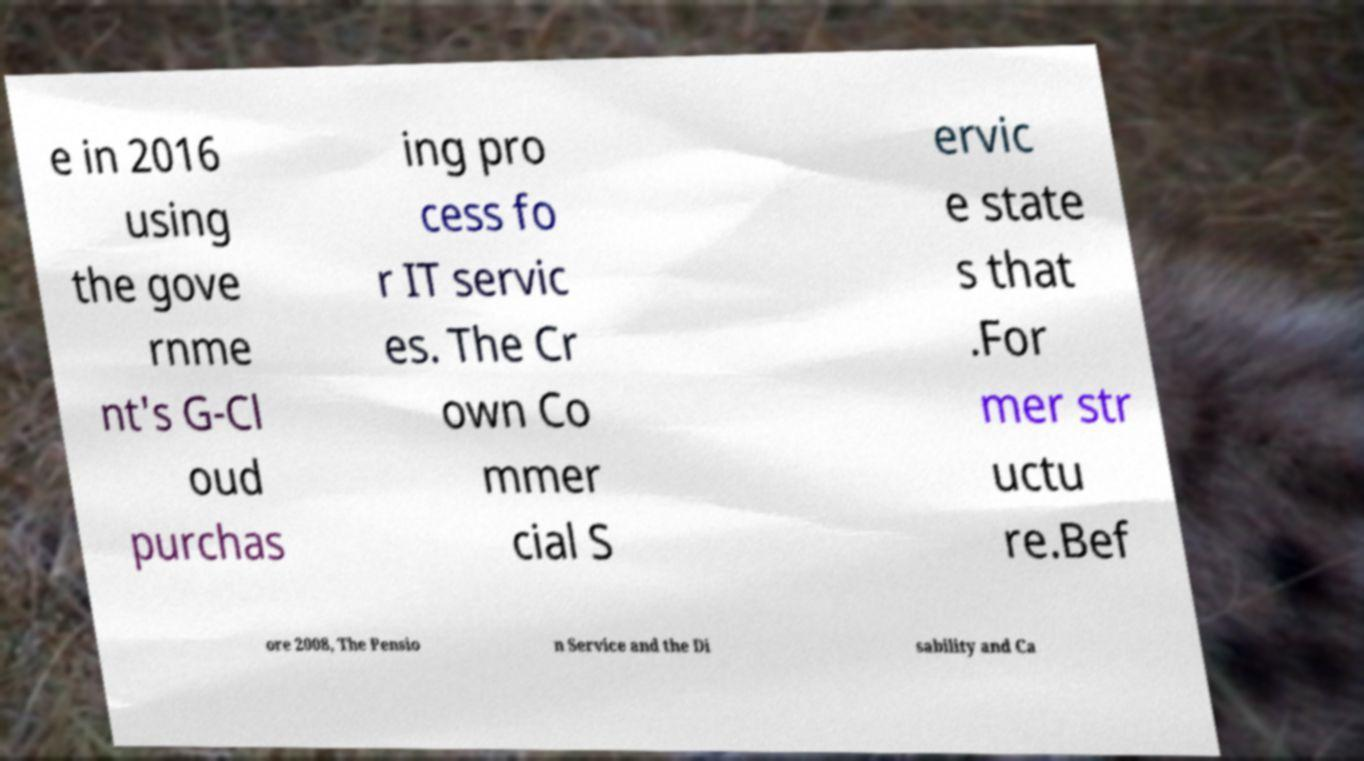Please read and relay the text visible in this image. What does it say? e in 2016 using the gove rnme nt's G-Cl oud purchas ing pro cess fo r IT servic es. The Cr own Co mmer cial S ervic e state s that .For mer str uctu re.Bef ore 2008, The Pensio n Service and the Di sability and Ca 